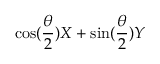Convert formula to latex. <formula><loc_0><loc_0><loc_500><loc_500>\cos ( \frac { \theta } { 2 } ) X + \sin ( \frac { \theta } { 2 } ) Y</formula> 